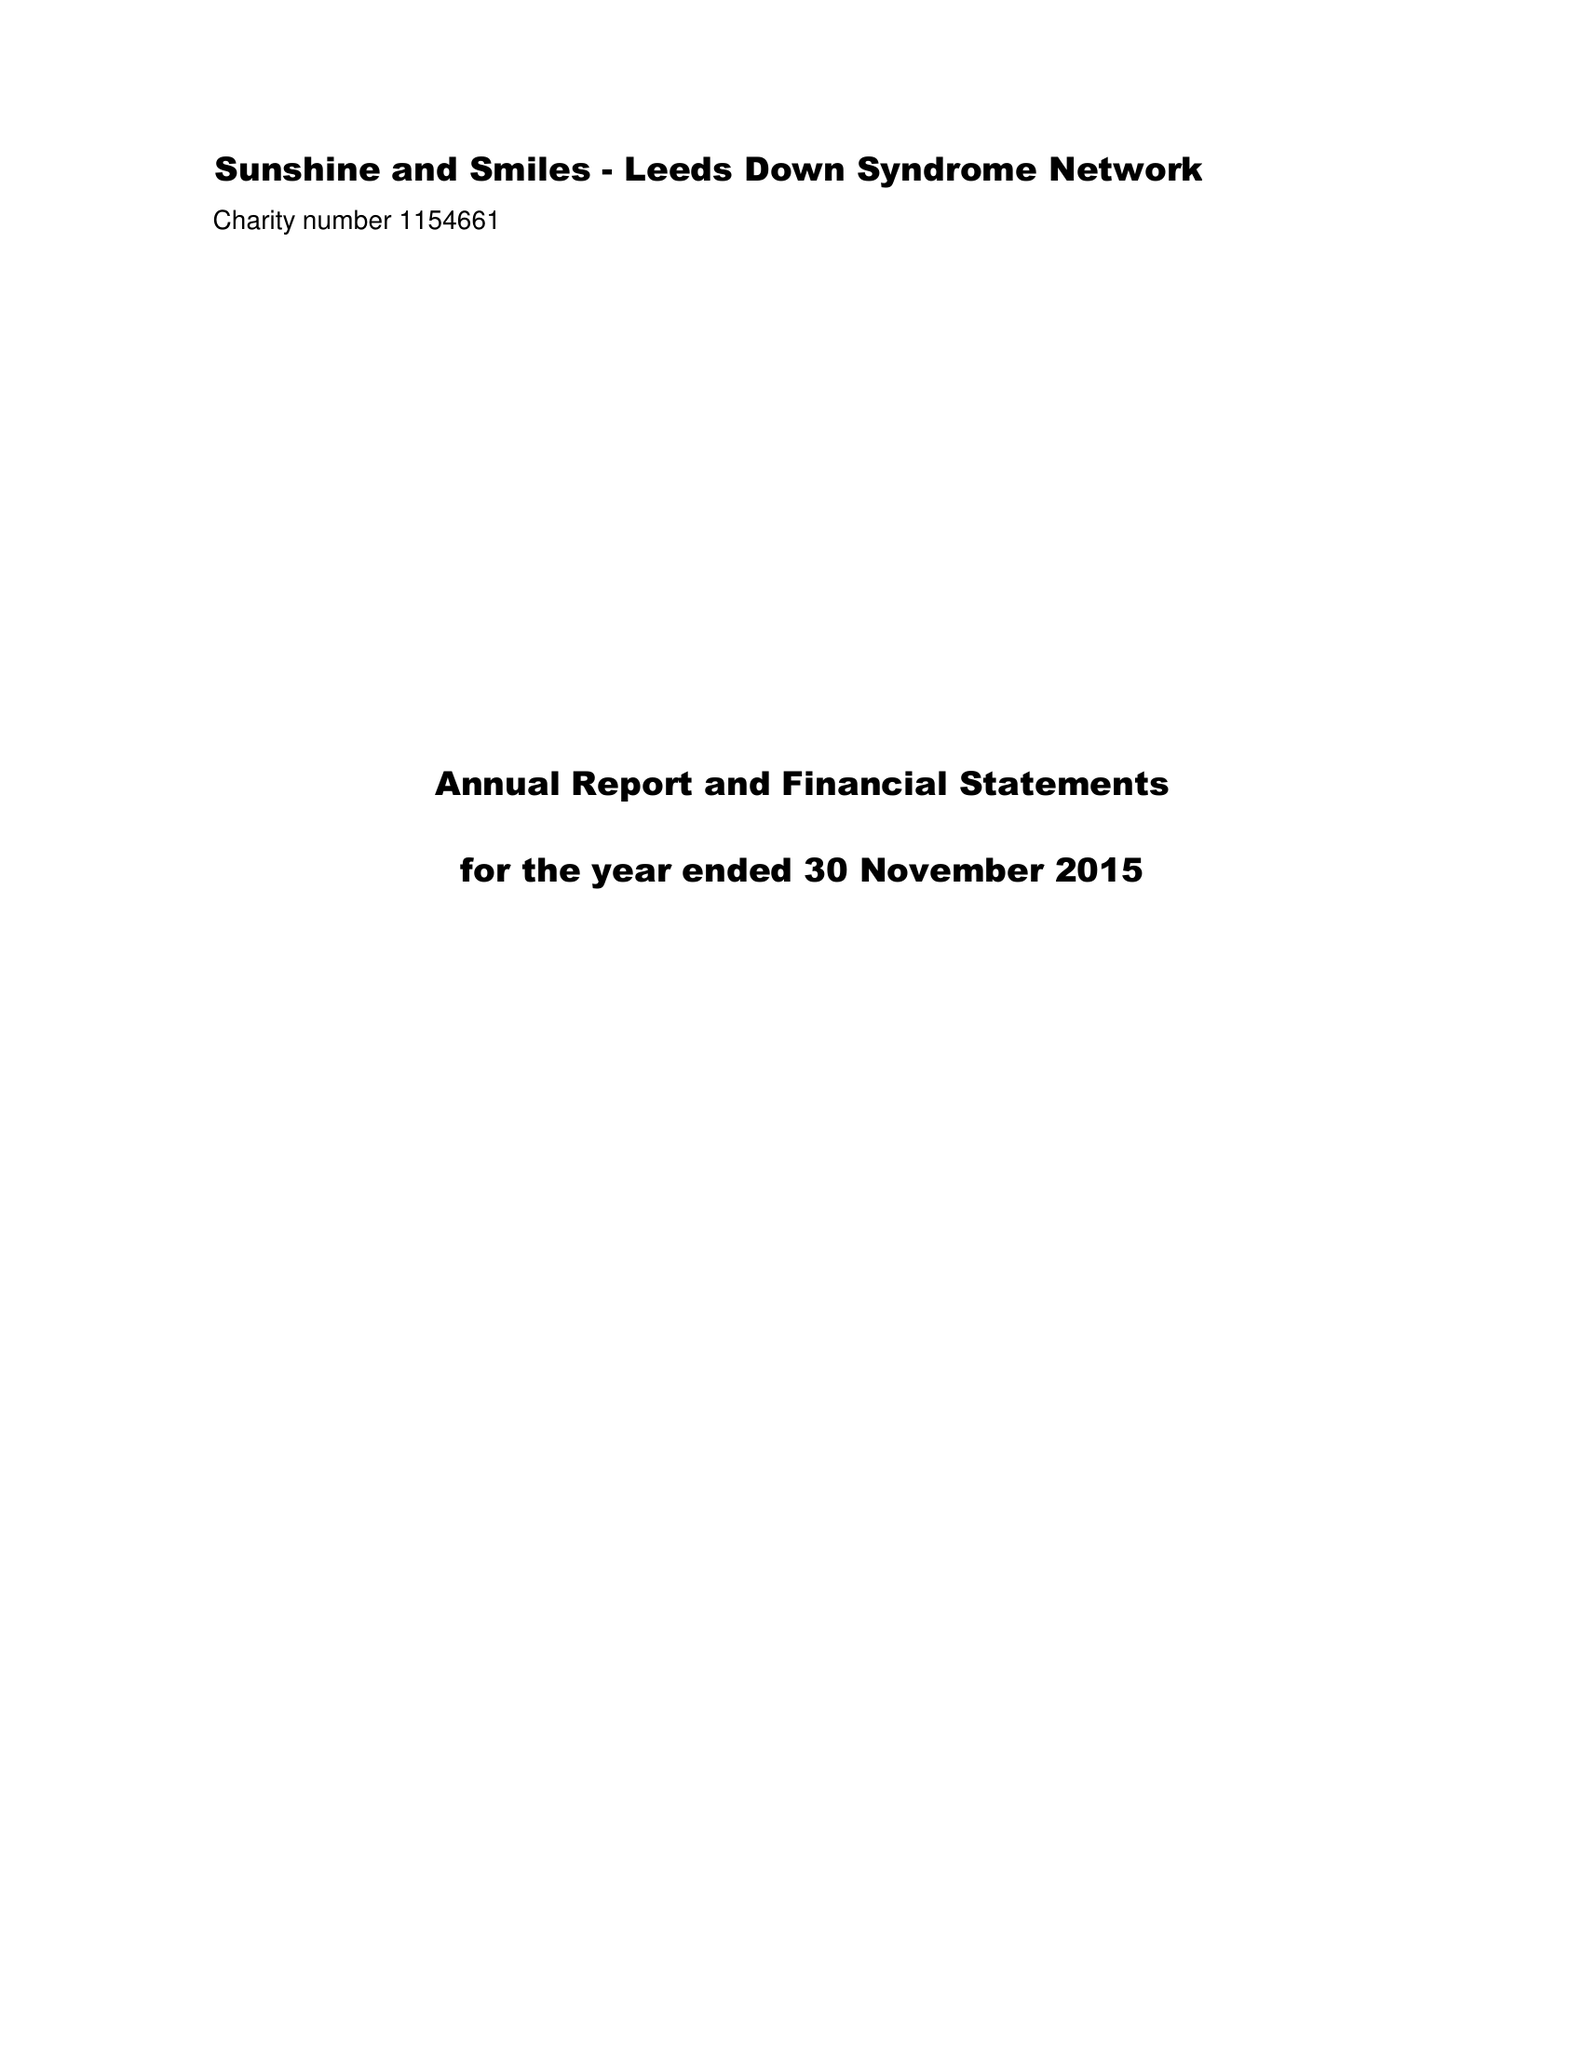What is the value for the address__street_line?
Answer the question using a single word or phrase. 3 DRUMMOND ROAD 